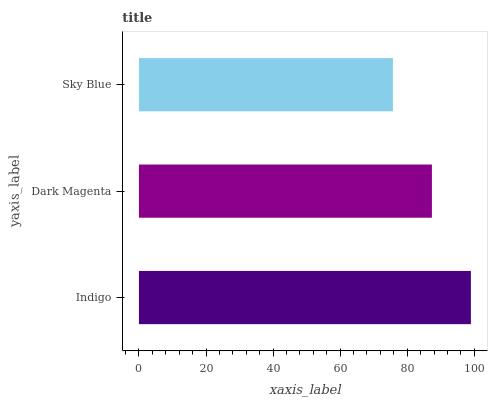Is Sky Blue the minimum?
Answer yes or no. Yes. Is Indigo the maximum?
Answer yes or no. Yes. Is Dark Magenta the minimum?
Answer yes or no. No. Is Dark Magenta the maximum?
Answer yes or no. No. Is Indigo greater than Dark Magenta?
Answer yes or no. Yes. Is Dark Magenta less than Indigo?
Answer yes or no. Yes. Is Dark Magenta greater than Indigo?
Answer yes or no. No. Is Indigo less than Dark Magenta?
Answer yes or no. No. Is Dark Magenta the high median?
Answer yes or no. Yes. Is Dark Magenta the low median?
Answer yes or no. Yes. Is Indigo the high median?
Answer yes or no. No. Is Indigo the low median?
Answer yes or no. No. 